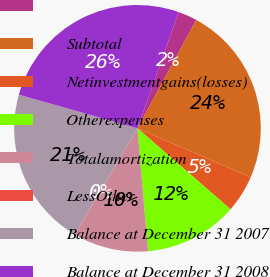<chart> <loc_0><loc_0><loc_500><loc_500><pie_chart><ecel><fcel>Subtotal<fcel>Netinvestmentgains(losses)<fcel>Otherexpenses<fcel>Totalamortization<fcel>LessOther<fcel>Balance at December 31 2007<fcel>Balance at December 31 2008<nl><fcel>2.48%<fcel>23.58%<fcel>4.92%<fcel>12.24%<fcel>9.8%<fcel>0.04%<fcel>20.92%<fcel>26.02%<nl></chart> 